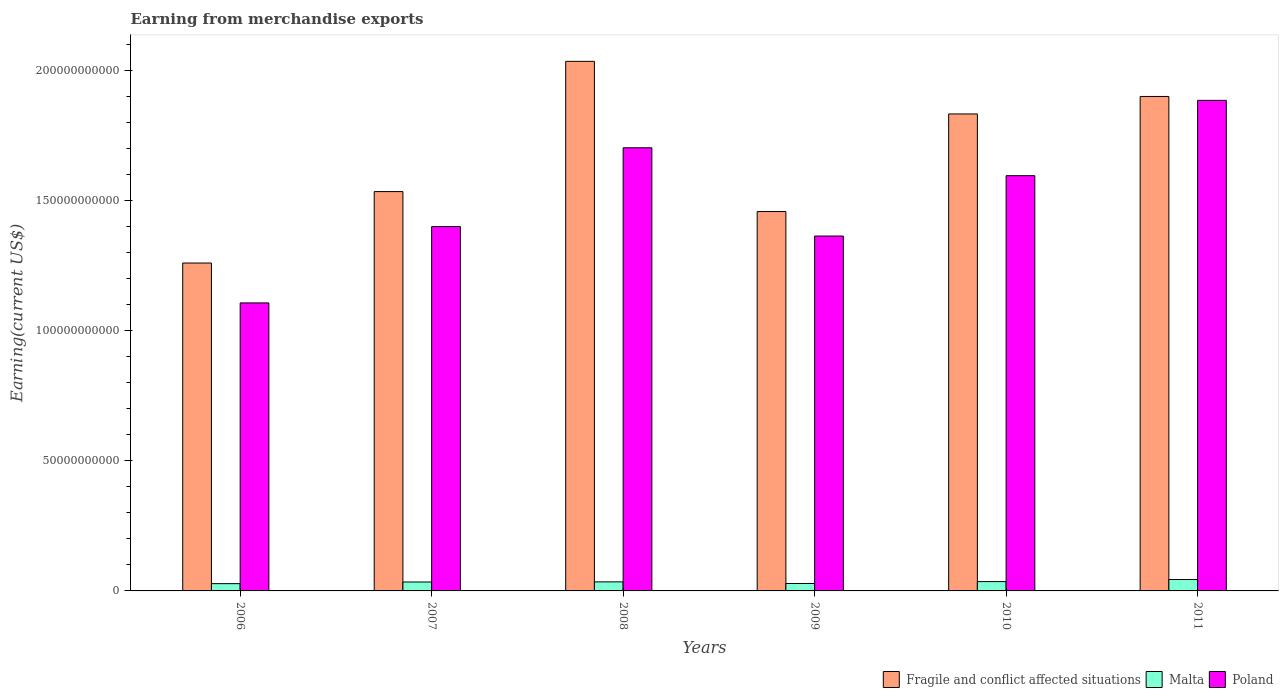How many different coloured bars are there?
Offer a terse response. 3. How many groups of bars are there?
Ensure brevity in your answer.  6. Are the number of bars per tick equal to the number of legend labels?
Offer a terse response. Yes. How many bars are there on the 4th tick from the right?
Your answer should be compact. 3. What is the amount earned from merchandise exports in Malta in 2009?
Provide a short and direct response. 2.86e+09. Across all years, what is the maximum amount earned from merchandise exports in Poland?
Give a very brief answer. 1.89e+11. Across all years, what is the minimum amount earned from merchandise exports in Poland?
Provide a succinct answer. 1.11e+11. In which year was the amount earned from merchandise exports in Malta maximum?
Ensure brevity in your answer.  2011. What is the total amount earned from merchandise exports in Fragile and conflict affected situations in the graph?
Give a very brief answer. 1.00e+12. What is the difference between the amount earned from merchandise exports in Malta in 2006 and that in 2010?
Your response must be concise. -7.90e+08. What is the difference between the amount earned from merchandise exports in Poland in 2007 and the amount earned from merchandise exports in Malta in 2009?
Give a very brief answer. 1.37e+11. What is the average amount earned from merchandise exports in Poland per year?
Your answer should be compact. 1.51e+11. In the year 2011, what is the difference between the amount earned from merchandise exports in Malta and amount earned from merchandise exports in Poland?
Make the answer very short. -1.84e+11. What is the ratio of the amount earned from merchandise exports in Fragile and conflict affected situations in 2010 to that in 2011?
Your answer should be very brief. 0.96. What is the difference between the highest and the second highest amount earned from merchandise exports in Fragile and conflict affected situations?
Offer a terse response. 1.35e+1. What is the difference between the highest and the lowest amount earned from merchandise exports in Malta?
Your answer should be very brief. 1.59e+09. Is the sum of the amount earned from merchandise exports in Malta in 2008 and 2009 greater than the maximum amount earned from merchandise exports in Poland across all years?
Your answer should be very brief. No. What does the 3rd bar from the left in 2008 represents?
Offer a terse response. Poland. What does the 1st bar from the right in 2010 represents?
Your response must be concise. Poland. How many bars are there?
Your answer should be very brief. 18. Are all the bars in the graph horizontal?
Ensure brevity in your answer.  No. How many years are there in the graph?
Provide a short and direct response. 6. What is the difference between two consecutive major ticks on the Y-axis?
Make the answer very short. 5.00e+1. Does the graph contain any zero values?
Offer a very short reply. No. Where does the legend appear in the graph?
Your answer should be very brief. Bottom right. What is the title of the graph?
Offer a very short reply. Earning from merchandise exports. What is the label or title of the Y-axis?
Provide a short and direct response. Earning(current US$). What is the Earning(current US$) in Fragile and conflict affected situations in 2006?
Ensure brevity in your answer.  1.26e+11. What is the Earning(current US$) in Malta in 2006?
Offer a very short reply. 2.80e+09. What is the Earning(current US$) in Poland in 2006?
Your response must be concise. 1.11e+11. What is the Earning(current US$) in Fragile and conflict affected situations in 2007?
Keep it short and to the point. 1.54e+11. What is the Earning(current US$) of Malta in 2007?
Provide a succinct answer. 3.44e+09. What is the Earning(current US$) in Poland in 2007?
Ensure brevity in your answer.  1.40e+11. What is the Earning(current US$) of Fragile and conflict affected situations in 2008?
Make the answer very short. 2.04e+11. What is the Earning(current US$) of Malta in 2008?
Provide a succinct answer. 3.48e+09. What is the Earning(current US$) in Poland in 2008?
Provide a succinct answer. 1.70e+11. What is the Earning(current US$) in Fragile and conflict affected situations in 2009?
Your answer should be compact. 1.46e+11. What is the Earning(current US$) in Malta in 2009?
Provide a short and direct response. 2.86e+09. What is the Earning(current US$) of Poland in 2009?
Offer a very short reply. 1.37e+11. What is the Earning(current US$) of Fragile and conflict affected situations in 2010?
Make the answer very short. 1.83e+11. What is the Earning(current US$) in Malta in 2010?
Make the answer very short. 3.59e+09. What is the Earning(current US$) of Poland in 2010?
Your answer should be compact. 1.60e+11. What is the Earning(current US$) in Fragile and conflict affected situations in 2011?
Offer a very short reply. 1.90e+11. What is the Earning(current US$) of Malta in 2011?
Provide a short and direct response. 4.39e+09. What is the Earning(current US$) in Poland in 2011?
Offer a terse response. 1.89e+11. Across all years, what is the maximum Earning(current US$) in Fragile and conflict affected situations?
Ensure brevity in your answer.  2.04e+11. Across all years, what is the maximum Earning(current US$) in Malta?
Offer a very short reply. 4.39e+09. Across all years, what is the maximum Earning(current US$) of Poland?
Offer a terse response. 1.89e+11. Across all years, what is the minimum Earning(current US$) in Fragile and conflict affected situations?
Offer a terse response. 1.26e+11. Across all years, what is the minimum Earning(current US$) in Malta?
Offer a very short reply. 2.80e+09. Across all years, what is the minimum Earning(current US$) of Poland?
Your answer should be compact. 1.11e+11. What is the total Earning(current US$) in Fragile and conflict affected situations in the graph?
Ensure brevity in your answer.  1.00e+12. What is the total Earning(current US$) in Malta in the graph?
Keep it short and to the point. 2.05e+1. What is the total Earning(current US$) of Poland in the graph?
Give a very brief answer. 9.06e+11. What is the difference between the Earning(current US$) in Fragile and conflict affected situations in 2006 and that in 2007?
Offer a terse response. -2.75e+1. What is the difference between the Earning(current US$) in Malta in 2006 and that in 2007?
Your answer should be compact. -6.41e+08. What is the difference between the Earning(current US$) of Poland in 2006 and that in 2007?
Your response must be concise. -2.94e+1. What is the difference between the Earning(current US$) of Fragile and conflict affected situations in 2006 and that in 2008?
Give a very brief answer. -7.76e+1. What is the difference between the Earning(current US$) of Malta in 2006 and that in 2008?
Ensure brevity in your answer.  -6.86e+08. What is the difference between the Earning(current US$) of Poland in 2006 and that in 2008?
Ensure brevity in your answer.  -5.97e+1. What is the difference between the Earning(current US$) of Fragile and conflict affected situations in 2006 and that in 2009?
Your answer should be compact. -1.98e+1. What is the difference between the Earning(current US$) in Malta in 2006 and that in 2009?
Ensure brevity in your answer.  -6.19e+07. What is the difference between the Earning(current US$) in Poland in 2006 and that in 2009?
Keep it short and to the point. -2.57e+1. What is the difference between the Earning(current US$) in Fragile and conflict affected situations in 2006 and that in 2010?
Your response must be concise. -5.73e+1. What is the difference between the Earning(current US$) in Malta in 2006 and that in 2010?
Keep it short and to the point. -7.90e+08. What is the difference between the Earning(current US$) in Poland in 2006 and that in 2010?
Offer a very short reply. -4.89e+1. What is the difference between the Earning(current US$) of Fragile and conflict affected situations in 2006 and that in 2011?
Your answer should be very brief. -6.41e+1. What is the difference between the Earning(current US$) of Malta in 2006 and that in 2011?
Offer a terse response. -1.59e+09. What is the difference between the Earning(current US$) of Poland in 2006 and that in 2011?
Provide a succinct answer. -7.79e+1. What is the difference between the Earning(current US$) in Fragile and conflict affected situations in 2007 and that in 2008?
Your answer should be very brief. -5.01e+1. What is the difference between the Earning(current US$) in Malta in 2007 and that in 2008?
Keep it short and to the point. -4.44e+07. What is the difference between the Earning(current US$) of Poland in 2007 and that in 2008?
Offer a terse response. -3.03e+1. What is the difference between the Earning(current US$) of Fragile and conflict affected situations in 2007 and that in 2009?
Provide a short and direct response. 7.68e+09. What is the difference between the Earning(current US$) of Malta in 2007 and that in 2009?
Offer a terse response. 5.80e+08. What is the difference between the Earning(current US$) in Poland in 2007 and that in 2009?
Offer a very short reply. 3.64e+09. What is the difference between the Earning(current US$) in Fragile and conflict affected situations in 2007 and that in 2010?
Provide a succinct answer. -2.99e+1. What is the difference between the Earning(current US$) of Malta in 2007 and that in 2010?
Your response must be concise. -1.49e+08. What is the difference between the Earning(current US$) of Poland in 2007 and that in 2010?
Keep it short and to the point. -1.96e+1. What is the difference between the Earning(current US$) in Fragile and conflict affected situations in 2007 and that in 2011?
Ensure brevity in your answer.  -3.66e+1. What is the difference between the Earning(current US$) of Malta in 2007 and that in 2011?
Provide a succinct answer. -9.49e+08. What is the difference between the Earning(current US$) of Poland in 2007 and that in 2011?
Ensure brevity in your answer.  -4.85e+1. What is the difference between the Earning(current US$) of Fragile and conflict affected situations in 2008 and that in 2009?
Ensure brevity in your answer.  5.78e+1. What is the difference between the Earning(current US$) of Malta in 2008 and that in 2009?
Give a very brief answer. 6.24e+08. What is the difference between the Earning(current US$) of Poland in 2008 and that in 2009?
Provide a succinct answer. 3.40e+1. What is the difference between the Earning(current US$) in Fragile and conflict affected situations in 2008 and that in 2010?
Keep it short and to the point. 2.02e+1. What is the difference between the Earning(current US$) in Malta in 2008 and that in 2010?
Provide a succinct answer. -1.05e+08. What is the difference between the Earning(current US$) in Poland in 2008 and that in 2010?
Offer a terse response. 1.07e+1. What is the difference between the Earning(current US$) in Fragile and conflict affected situations in 2008 and that in 2011?
Give a very brief answer. 1.35e+1. What is the difference between the Earning(current US$) of Malta in 2008 and that in 2011?
Offer a very short reply. -9.04e+08. What is the difference between the Earning(current US$) in Poland in 2008 and that in 2011?
Keep it short and to the point. -1.82e+1. What is the difference between the Earning(current US$) of Fragile and conflict affected situations in 2009 and that in 2010?
Keep it short and to the point. -3.75e+1. What is the difference between the Earning(current US$) of Malta in 2009 and that in 2010?
Your response must be concise. -7.28e+08. What is the difference between the Earning(current US$) in Poland in 2009 and that in 2010?
Offer a terse response. -2.32e+1. What is the difference between the Earning(current US$) of Fragile and conflict affected situations in 2009 and that in 2011?
Ensure brevity in your answer.  -4.43e+1. What is the difference between the Earning(current US$) of Malta in 2009 and that in 2011?
Offer a very short reply. -1.53e+09. What is the difference between the Earning(current US$) of Poland in 2009 and that in 2011?
Offer a terse response. -5.22e+1. What is the difference between the Earning(current US$) in Fragile and conflict affected situations in 2010 and that in 2011?
Give a very brief answer. -6.73e+09. What is the difference between the Earning(current US$) in Malta in 2010 and that in 2011?
Provide a succinct answer. -8.00e+08. What is the difference between the Earning(current US$) of Poland in 2010 and that in 2011?
Your response must be concise. -2.90e+1. What is the difference between the Earning(current US$) in Fragile and conflict affected situations in 2006 and the Earning(current US$) in Malta in 2007?
Your response must be concise. 1.23e+11. What is the difference between the Earning(current US$) of Fragile and conflict affected situations in 2006 and the Earning(current US$) of Poland in 2007?
Your response must be concise. -1.40e+1. What is the difference between the Earning(current US$) in Malta in 2006 and the Earning(current US$) in Poland in 2007?
Your answer should be very brief. -1.37e+11. What is the difference between the Earning(current US$) of Fragile and conflict affected situations in 2006 and the Earning(current US$) of Malta in 2008?
Ensure brevity in your answer.  1.23e+11. What is the difference between the Earning(current US$) in Fragile and conflict affected situations in 2006 and the Earning(current US$) in Poland in 2008?
Your answer should be compact. -4.43e+1. What is the difference between the Earning(current US$) of Malta in 2006 and the Earning(current US$) of Poland in 2008?
Offer a very short reply. -1.68e+11. What is the difference between the Earning(current US$) of Fragile and conflict affected situations in 2006 and the Earning(current US$) of Malta in 2009?
Your answer should be compact. 1.23e+11. What is the difference between the Earning(current US$) in Fragile and conflict affected situations in 2006 and the Earning(current US$) in Poland in 2009?
Keep it short and to the point. -1.04e+1. What is the difference between the Earning(current US$) in Malta in 2006 and the Earning(current US$) in Poland in 2009?
Ensure brevity in your answer.  -1.34e+11. What is the difference between the Earning(current US$) of Fragile and conflict affected situations in 2006 and the Earning(current US$) of Malta in 2010?
Provide a succinct answer. 1.23e+11. What is the difference between the Earning(current US$) in Fragile and conflict affected situations in 2006 and the Earning(current US$) in Poland in 2010?
Your answer should be compact. -3.36e+1. What is the difference between the Earning(current US$) of Malta in 2006 and the Earning(current US$) of Poland in 2010?
Your response must be concise. -1.57e+11. What is the difference between the Earning(current US$) in Fragile and conflict affected situations in 2006 and the Earning(current US$) in Malta in 2011?
Your answer should be very brief. 1.22e+11. What is the difference between the Earning(current US$) in Fragile and conflict affected situations in 2006 and the Earning(current US$) in Poland in 2011?
Your response must be concise. -6.26e+1. What is the difference between the Earning(current US$) of Malta in 2006 and the Earning(current US$) of Poland in 2011?
Your response must be concise. -1.86e+11. What is the difference between the Earning(current US$) in Fragile and conflict affected situations in 2007 and the Earning(current US$) in Malta in 2008?
Provide a succinct answer. 1.50e+11. What is the difference between the Earning(current US$) of Fragile and conflict affected situations in 2007 and the Earning(current US$) of Poland in 2008?
Offer a very short reply. -1.69e+1. What is the difference between the Earning(current US$) in Malta in 2007 and the Earning(current US$) in Poland in 2008?
Offer a terse response. -1.67e+11. What is the difference between the Earning(current US$) of Fragile and conflict affected situations in 2007 and the Earning(current US$) of Malta in 2009?
Your answer should be compact. 1.51e+11. What is the difference between the Earning(current US$) in Fragile and conflict affected situations in 2007 and the Earning(current US$) in Poland in 2009?
Keep it short and to the point. 1.71e+1. What is the difference between the Earning(current US$) of Malta in 2007 and the Earning(current US$) of Poland in 2009?
Your answer should be compact. -1.33e+11. What is the difference between the Earning(current US$) of Fragile and conflict affected situations in 2007 and the Earning(current US$) of Malta in 2010?
Provide a short and direct response. 1.50e+11. What is the difference between the Earning(current US$) of Fragile and conflict affected situations in 2007 and the Earning(current US$) of Poland in 2010?
Your answer should be compact. -6.12e+09. What is the difference between the Earning(current US$) in Malta in 2007 and the Earning(current US$) in Poland in 2010?
Provide a short and direct response. -1.56e+11. What is the difference between the Earning(current US$) of Fragile and conflict affected situations in 2007 and the Earning(current US$) of Malta in 2011?
Provide a succinct answer. 1.49e+11. What is the difference between the Earning(current US$) in Fragile and conflict affected situations in 2007 and the Earning(current US$) in Poland in 2011?
Offer a very short reply. -3.51e+1. What is the difference between the Earning(current US$) in Malta in 2007 and the Earning(current US$) in Poland in 2011?
Offer a very short reply. -1.85e+11. What is the difference between the Earning(current US$) of Fragile and conflict affected situations in 2008 and the Earning(current US$) of Malta in 2009?
Keep it short and to the point. 2.01e+11. What is the difference between the Earning(current US$) of Fragile and conflict affected situations in 2008 and the Earning(current US$) of Poland in 2009?
Your answer should be very brief. 6.72e+1. What is the difference between the Earning(current US$) of Malta in 2008 and the Earning(current US$) of Poland in 2009?
Offer a very short reply. -1.33e+11. What is the difference between the Earning(current US$) of Fragile and conflict affected situations in 2008 and the Earning(current US$) of Malta in 2010?
Keep it short and to the point. 2.00e+11. What is the difference between the Earning(current US$) of Fragile and conflict affected situations in 2008 and the Earning(current US$) of Poland in 2010?
Your answer should be compact. 4.40e+1. What is the difference between the Earning(current US$) of Malta in 2008 and the Earning(current US$) of Poland in 2010?
Offer a terse response. -1.56e+11. What is the difference between the Earning(current US$) of Fragile and conflict affected situations in 2008 and the Earning(current US$) of Malta in 2011?
Make the answer very short. 1.99e+11. What is the difference between the Earning(current US$) of Fragile and conflict affected situations in 2008 and the Earning(current US$) of Poland in 2011?
Provide a short and direct response. 1.50e+1. What is the difference between the Earning(current US$) of Malta in 2008 and the Earning(current US$) of Poland in 2011?
Keep it short and to the point. -1.85e+11. What is the difference between the Earning(current US$) in Fragile and conflict affected situations in 2009 and the Earning(current US$) in Malta in 2010?
Your answer should be compact. 1.42e+11. What is the difference between the Earning(current US$) in Fragile and conflict affected situations in 2009 and the Earning(current US$) in Poland in 2010?
Your answer should be very brief. -1.38e+1. What is the difference between the Earning(current US$) of Malta in 2009 and the Earning(current US$) of Poland in 2010?
Your answer should be very brief. -1.57e+11. What is the difference between the Earning(current US$) in Fragile and conflict affected situations in 2009 and the Earning(current US$) in Malta in 2011?
Offer a terse response. 1.42e+11. What is the difference between the Earning(current US$) of Fragile and conflict affected situations in 2009 and the Earning(current US$) of Poland in 2011?
Your answer should be compact. -4.28e+1. What is the difference between the Earning(current US$) in Malta in 2009 and the Earning(current US$) in Poland in 2011?
Provide a succinct answer. -1.86e+11. What is the difference between the Earning(current US$) of Fragile and conflict affected situations in 2010 and the Earning(current US$) of Malta in 2011?
Your response must be concise. 1.79e+11. What is the difference between the Earning(current US$) in Fragile and conflict affected situations in 2010 and the Earning(current US$) in Poland in 2011?
Ensure brevity in your answer.  -5.23e+09. What is the difference between the Earning(current US$) in Malta in 2010 and the Earning(current US$) in Poland in 2011?
Give a very brief answer. -1.85e+11. What is the average Earning(current US$) in Fragile and conflict affected situations per year?
Your answer should be compact. 1.67e+11. What is the average Earning(current US$) in Malta per year?
Give a very brief answer. 3.42e+09. What is the average Earning(current US$) of Poland per year?
Offer a very short reply. 1.51e+11. In the year 2006, what is the difference between the Earning(current US$) of Fragile and conflict affected situations and Earning(current US$) of Malta?
Provide a succinct answer. 1.23e+11. In the year 2006, what is the difference between the Earning(current US$) in Fragile and conflict affected situations and Earning(current US$) in Poland?
Provide a short and direct response. 1.53e+1. In the year 2006, what is the difference between the Earning(current US$) in Malta and Earning(current US$) in Poland?
Your answer should be very brief. -1.08e+11. In the year 2007, what is the difference between the Earning(current US$) of Fragile and conflict affected situations and Earning(current US$) of Malta?
Provide a succinct answer. 1.50e+11. In the year 2007, what is the difference between the Earning(current US$) of Fragile and conflict affected situations and Earning(current US$) of Poland?
Your answer should be compact. 1.35e+1. In the year 2007, what is the difference between the Earning(current US$) of Malta and Earning(current US$) of Poland?
Ensure brevity in your answer.  -1.37e+11. In the year 2008, what is the difference between the Earning(current US$) of Fragile and conflict affected situations and Earning(current US$) of Malta?
Make the answer very short. 2.00e+11. In the year 2008, what is the difference between the Earning(current US$) in Fragile and conflict affected situations and Earning(current US$) in Poland?
Your response must be concise. 3.32e+1. In the year 2008, what is the difference between the Earning(current US$) in Malta and Earning(current US$) in Poland?
Offer a very short reply. -1.67e+11. In the year 2009, what is the difference between the Earning(current US$) of Fragile and conflict affected situations and Earning(current US$) of Malta?
Ensure brevity in your answer.  1.43e+11. In the year 2009, what is the difference between the Earning(current US$) of Fragile and conflict affected situations and Earning(current US$) of Poland?
Make the answer very short. 9.42e+09. In the year 2009, what is the difference between the Earning(current US$) in Malta and Earning(current US$) in Poland?
Your answer should be compact. -1.34e+11. In the year 2010, what is the difference between the Earning(current US$) in Fragile and conflict affected situations and Earning(current US$) in Malta?
Your answer should be compact. 1.80e+11. In the year 2010, what is the difference between the Earning(current US$) of Fragile and conflict affected situations and Earning(current US$) of Poland?
Ensure brevity in your answer.  2.37e+1. In the year 2010, what is the difference between the Earning(current US$) of Malta and Earning(current US$) of Poland?
Provide a succinct answer. -1.56e+11. In the year 2011, what is the difference between the Earning(current US$) of Fragile and conflict affected situations and Earning(current US$) of Malta?
Offer a terse response. 1.86e+11. In the year 2011, what is the difference between the Earning(current US$) in Fragile and conflict affected situations and Earning(current US$) in Poland?
Offer a terse response. 1.50e+09. In the year 2011, what is the difference between the Earning(current US$) of Malta and Earning(current US$) of Poland?
Your answer should be very brief. -1.84e+11. What is the ratio of the Earning(current US$) of Fragile and conflict affected situations in 2006 to that in 2007?
Provide a succinct answer. 0.82. What is the ratio of the Earning(current US$) in Malta in 2006 to that in 2007?
Make the answer very short. 0.81. What is the ratio of the Earning(current US$) of Poland in 2006 to that in 2007?
Give a very brief answer. 0.79. What is the ratio of the Earning(current US$) of Fragile and conflict affected situations in 2006 to that in 2008?
Offer a terse response. 0.62. What is the ratio of the Earning(current US$) of Malta in 2006 to that in 2008?
Provide a short and direct response. 0.8. What is the ratio of the Earning(current US$) of Poland in 2006 to that in 2008?
Your response must be concise. 0.65. What is the ratio of the Earning(current US$) in Fragile and conflict affected situations in 2006 to that in 2009?
Your answer should be very brief. 0.86. What is the ratio of the Earning(current US$) in Malta in 2006 to that in 2009?
Provide a short and direct response. 0.98. What is the ratio of the Earning(current US$) of Poland in 2006 to that in 2009?
Provide a succinct answer. 0.81. What is the ratio of the Earning(current US$) in Fragile and conflict affected situations in 2006 to that in 2010?
Offer a terse response. 0.69. What is the ratio of the Earning(current US$) in Malta in 2006 to that in 2010?
Provide a short and direct response. 0.78. What is the ratio of the Earning(current US$) of Poland in 2006 to that in 2010?
Provide a short and direct response. 0.69. What is the ratio of the Earning(current US$) of Fragile and conflict affected situations in 2006 to that in 2011?
Your answer should be very brief. 0.66. What is the ratio of the Earning(current US$) in Malta in 2006 to that in 2011?
Your response must be concise. 0.64. What is the ratio of the Earning(current US$) of Poland in 2006 to that in 2011?
Ensure brevity in your answer.  0.59. What is the ratio of the Earning(current US$) in Fragile and conflict affected situations in 2007 to that in 2008?
Ensure brevity in your answer.  0.75. What is the ratio of the Earning(current US$) in Malta in 2007 to that in 2008?
Give a very brief answer. 0.99. What is the ratio of the Earning(current US$) of Poland in 2007 to that in 2008?
Offer a very short reply. 0.82. What is the ratio of the Earning(current US$) of Fragile and conflict affected situations in 2007 to that in 2009?
Your answer should be very brief. 1.05. What is the ratio of the Earning(current US$) of Malta in 2007 to that in 2009?
Provide a succinct answer. 1.2. What is the ratio of the Earning(current US$) of Poland in 2007 to that in 2009?
Your answer should be compact. 1.03. What is the ratio of the Earning(current US$) in Fragile and conflict affected situations in 2007 to that in 2010?
Your response must be concise. 0.84. What is the ratio of the Earning(current US$) of Malta in 2007 to that in 2010?
Ensure brevity in your answer.  0.96. What is the ratio of the Earning(current US$) of Poland in 2007 to that in 2010?
Make the answer very short. 0.88. What is the ratio of the Earning(current US$) in Fragile and conflict affected situations in 2007 to that in 2011?
Offer a very short reply. 0.81. What is the ratio of the Earning(current US$) in Malta in 2007 to that in 2011?
Offer a terse response. 0.78. What is the ratio of the Earning(current US$) in Poland in 2007 to that in 2011?
Provide a succinct answer. 0.74. What is the ratio of the Earning(current US$) of Fragile and conflict affected situations in 2008 to that in 2009?
Offer a very short reply. 1.4. What is the ratio of the Earning(current US$) in Malta in 2008 to that in 2009?
Provide a short and direct response. 1.22. What is the ratio of the Earning(current US$) of Poland in 2008 to that in 2009?
Offer a very short reply. 1.25. What is the ratio of the Earning(current US$) in Fragile and conflict affected situations in 2008 to that in 2010?
Provide a short and direct response. 1.11. What is the ratio of the Earning(current US$) of Malta in 2008 to that in 2010?
Provide a succinct answer. 0.97. What is the ratio of the Earning(current US$) of Poland in 2008 to that in 2010?
Your response must be concise. 1.07. What is the ratio of the Earning(current US$) of Fragile and conflict affected situations in 2008 to that in 2011?
Your answer should be very brief. 1.07. What is the ratio of the Earning(current US$) in Malta in 2008 to that in 2011?
Provide a short and direct response. 0.79. What is the ratio of the Earning(current US$) of Poland in 2008 to that in 2011?
Make the answer very short. 0.9. What is the ratio of the Earning(current US$) in Fragile and conflict affected situations in 2009 to that in 2010?
Make the answer very short. 0.8. What is the ratio of the Earning(current US$) of Malta in 2009 to that in 2010?
Keep it short and to the point. 0.8. What is the ratio of the Earning(current US$) in Poland in 2009 to that in 2010?
Your answer should be compact. 0.85. What is the ratio of the Earning(current US$) in Fragile and conflict affected situations in 2009 to that in 2011?
Your response must be concise. 0.77. What is the ratio of the Earning(current US$) in Malta in 2009 to that in 2011?
Your answer should be compact. 0.65. What is the ratio of the Earning(current US$) of Poland in 2009 to that in 2011?
Offer a terse response. 0.72. What is the ratio of the Earning(current US$) of Fragile and conflict affected situations in 2010 to that in 2011?
Offer a very short reply. 0.96. What is the ratio of the Earning(current US$) of Malta in 2010 to that in 2011?
Your response must be concise. 0.82. What is the ratio of the Earning(current US$) of Poland in 2010 to that in 2011?
Offer a very short reply. 0.85. What is the difference between the highest and the second highest Earning(current US$) in Fragile and conflict affected situations?
Your answer should be very brief. 1.35e+1. What is the difference between the highest and the second highest Earning(current US$) in Malta?
Ensure brevity in your answer.  8.00e+08. What is the difference between the highest and the second highest Earning(current US$) in Poland?
Ensure brevity in your answer.  1.82e+1. What is the difference between the highest and the lowest Earning(current US$) in Fragile and conflict affected situations?
Offer a very short reply. 7.76e+1. What is the difference between the highest and the lowest Earning(current US$) of Malta?
Make the answer very short. 1.59e+09. What is the difference between the highest and the lowest Earning(current US$) of Poland?
Provide a short and direct response. 7.79e+1. 